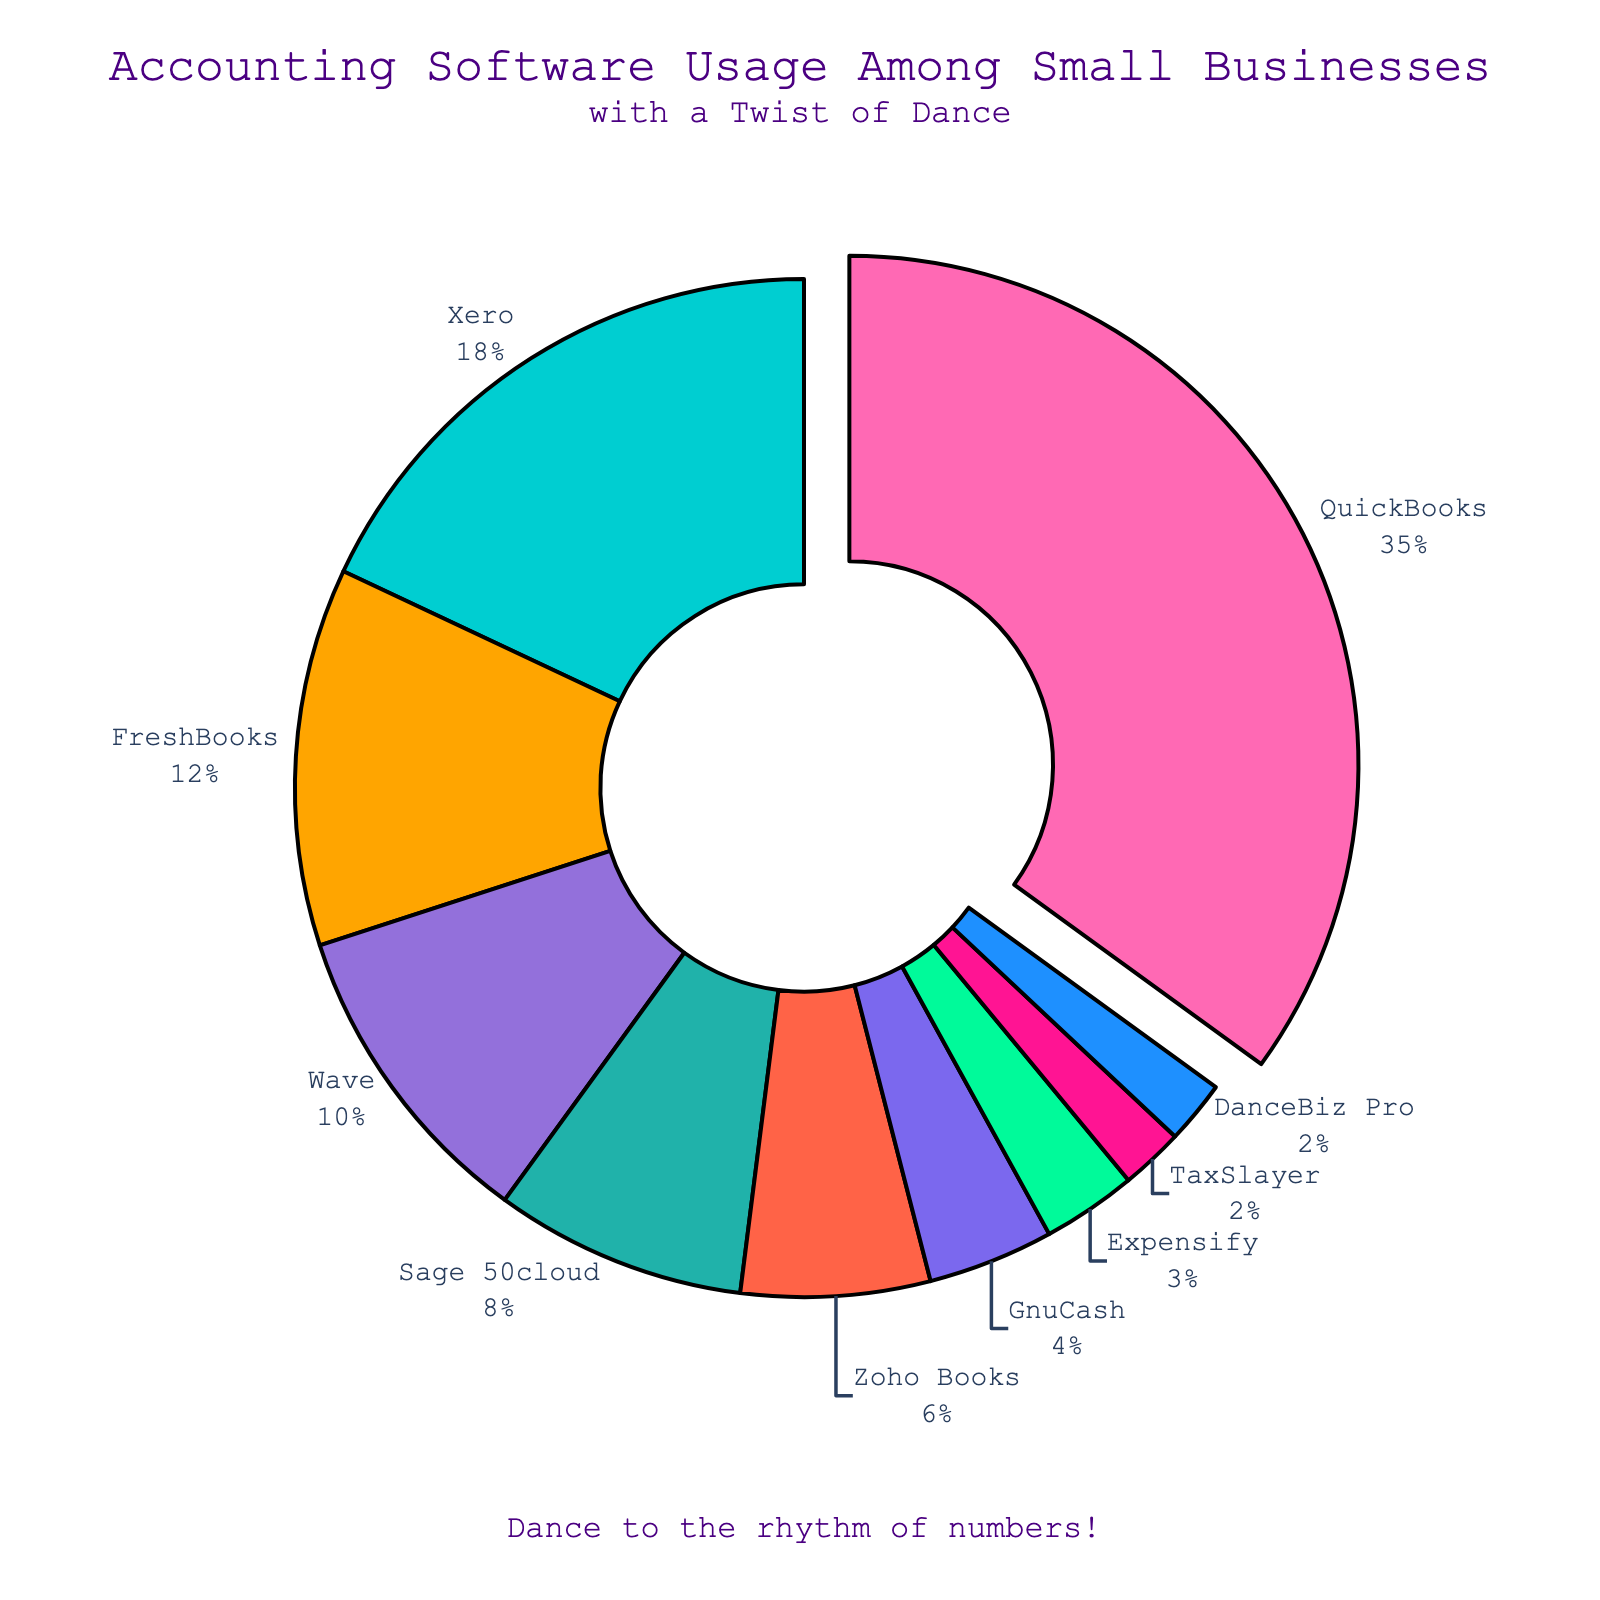Which software has the highest usage among small businesses? The figure highlights that QuickBooks has the largest portion of the pie chart. It is also pulled out slightly from the center to emphasize its dominance.
Answer: QuickBooks What percentage of small businesses use Xero in comparison to QuickBooks? Xero accounts for 18% of the software usage, while QuickBooks accounts for 35%. Comparing the two percentages, Xero's usage is 18/35 or approximately 51.4% of QuickBooks' usage.
Answer: Approximately 51.4% How many software options are used by less than 10% of small businesses? The pie chart shows Wave, Sage 50cloud, Zoho Books, GnuCash, Expensify, TaxSlayer, and DanceBiz Pro under 10% sections. Counting them gives a total of 7 options.
Answer: 7 What is the combined percentage usage of QuickBooks, Xero, and FreshBooks? QuickBooks is 35%, Xero is 18%, and FreshBooks is 12%. Adding these percentages together gives 35 + 18 + 12 = 65%.
Answer: 65% What is the least used software among small businesses according to the pie chart? The smallest portion of the pie chart belongs to both TaxSlayer and DanceBiz Pro, each representing 2% of the total usage.
Answer: TaxSlayer and DanceBiz Pro Which software usage is represented by the blue-colored section in the pie chart? The pie chart shows that the blue-colored section corresponds to DanceBiz Pro, which has a 2% usage shared.
Answer: DanceBiz Pro Compare the combined percentage of usage for Wave and Sage 50cloud versus Zoho Books and GnuCash. Which group has a higher usage? Wave is 10%, Sage 50cloud is 8%, Zoho Books is 6%, and GnuCash is 4%. The combined percentage for Wave and Sage is 10 + 8 = 18%. The combined percentage for Zoho Books and GnuCash is 6 + 4 = 10%. Therefore, Wave and Sage 50cloud's combined usage is higher.
Answer: Wave and Sage 50cloud What is the difference in the percentage usage between the most and least popular software? The most popular software, QuickBooks, has a usage percentage of 35%, while the least popular softwares, TaxSlayer and DanceBiz Pro, each have 2%. The difference is 35 - 2 = 33%.
Answer: 33% 